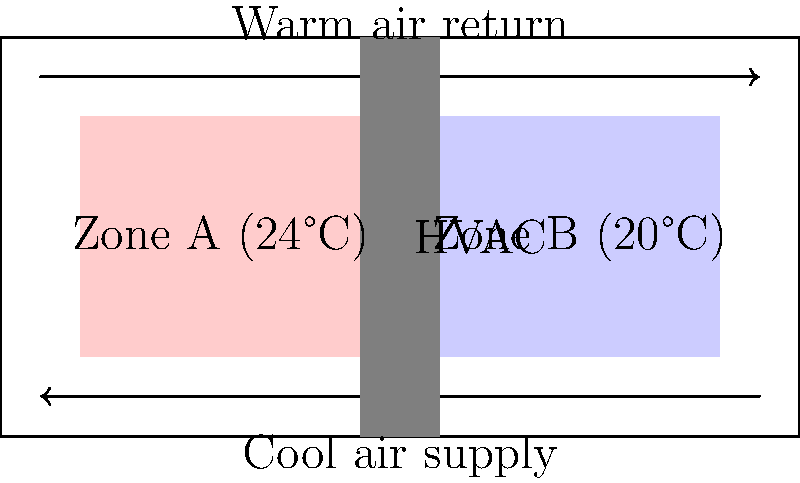On your family's magical Disney cruise, you notice that different areas of the ship have different temperatures. The schematic shows two zones: Zone A at 24°C and Zone B at 20°C. If the HVAC system is designed to maintain a temperature difference of 4°C between the zones, what is the cooling capacity required for Zone B in kW, assuming it has a volume of 1000 m³ and receives 200 W/m³ of heat from various sources (people, equipment, etc.)? Let's approach this step-by-step:

1. Understand the given information:
   - Zone B temperature: 20°C
   - Temperature difference between zones: 4°C
   - Volume of Zone B: 1000 m³
   - Heat input: 200 W/m³

2. Calculate the total heat input to Zone B:
   $Q_{input} = 200 \text{ W/m³} \times 1000 \text{ m³} = 200,000 \text{ W} = 200 \text{ kW}$

3. To maintain the temperature difference, the cooling system must remove all this heat plus any additional heat transfer from Zone A.

4. The heat transfer between zones can be estimated using the basic heat transfer equation:
   $Q = UA\Delta T$
   Where U is the overall heat transfer coefficient, A is the surface area, and $\Delta T$ is the temperature difference.

5. Without specific information about U and A, we can estimate that this additional heat transfer is approximately 10% of the internal heat generation.
   $Q_{transfer} \approx 0.1 \times 200 \text{ kW} = 20 \text{ kW}$

6. The total cooling capacity required is the sum of internal heat generation and heat transfer:
   $Q_{total} = Q_{input} + Q_{transfer} = 200 \text{ kW} + 20 \text{ kW} = 220 \text{ kW}$

Therefore, the cooling capacity required for Zone B is approximately 220 kW.
Answer: 220 kW 